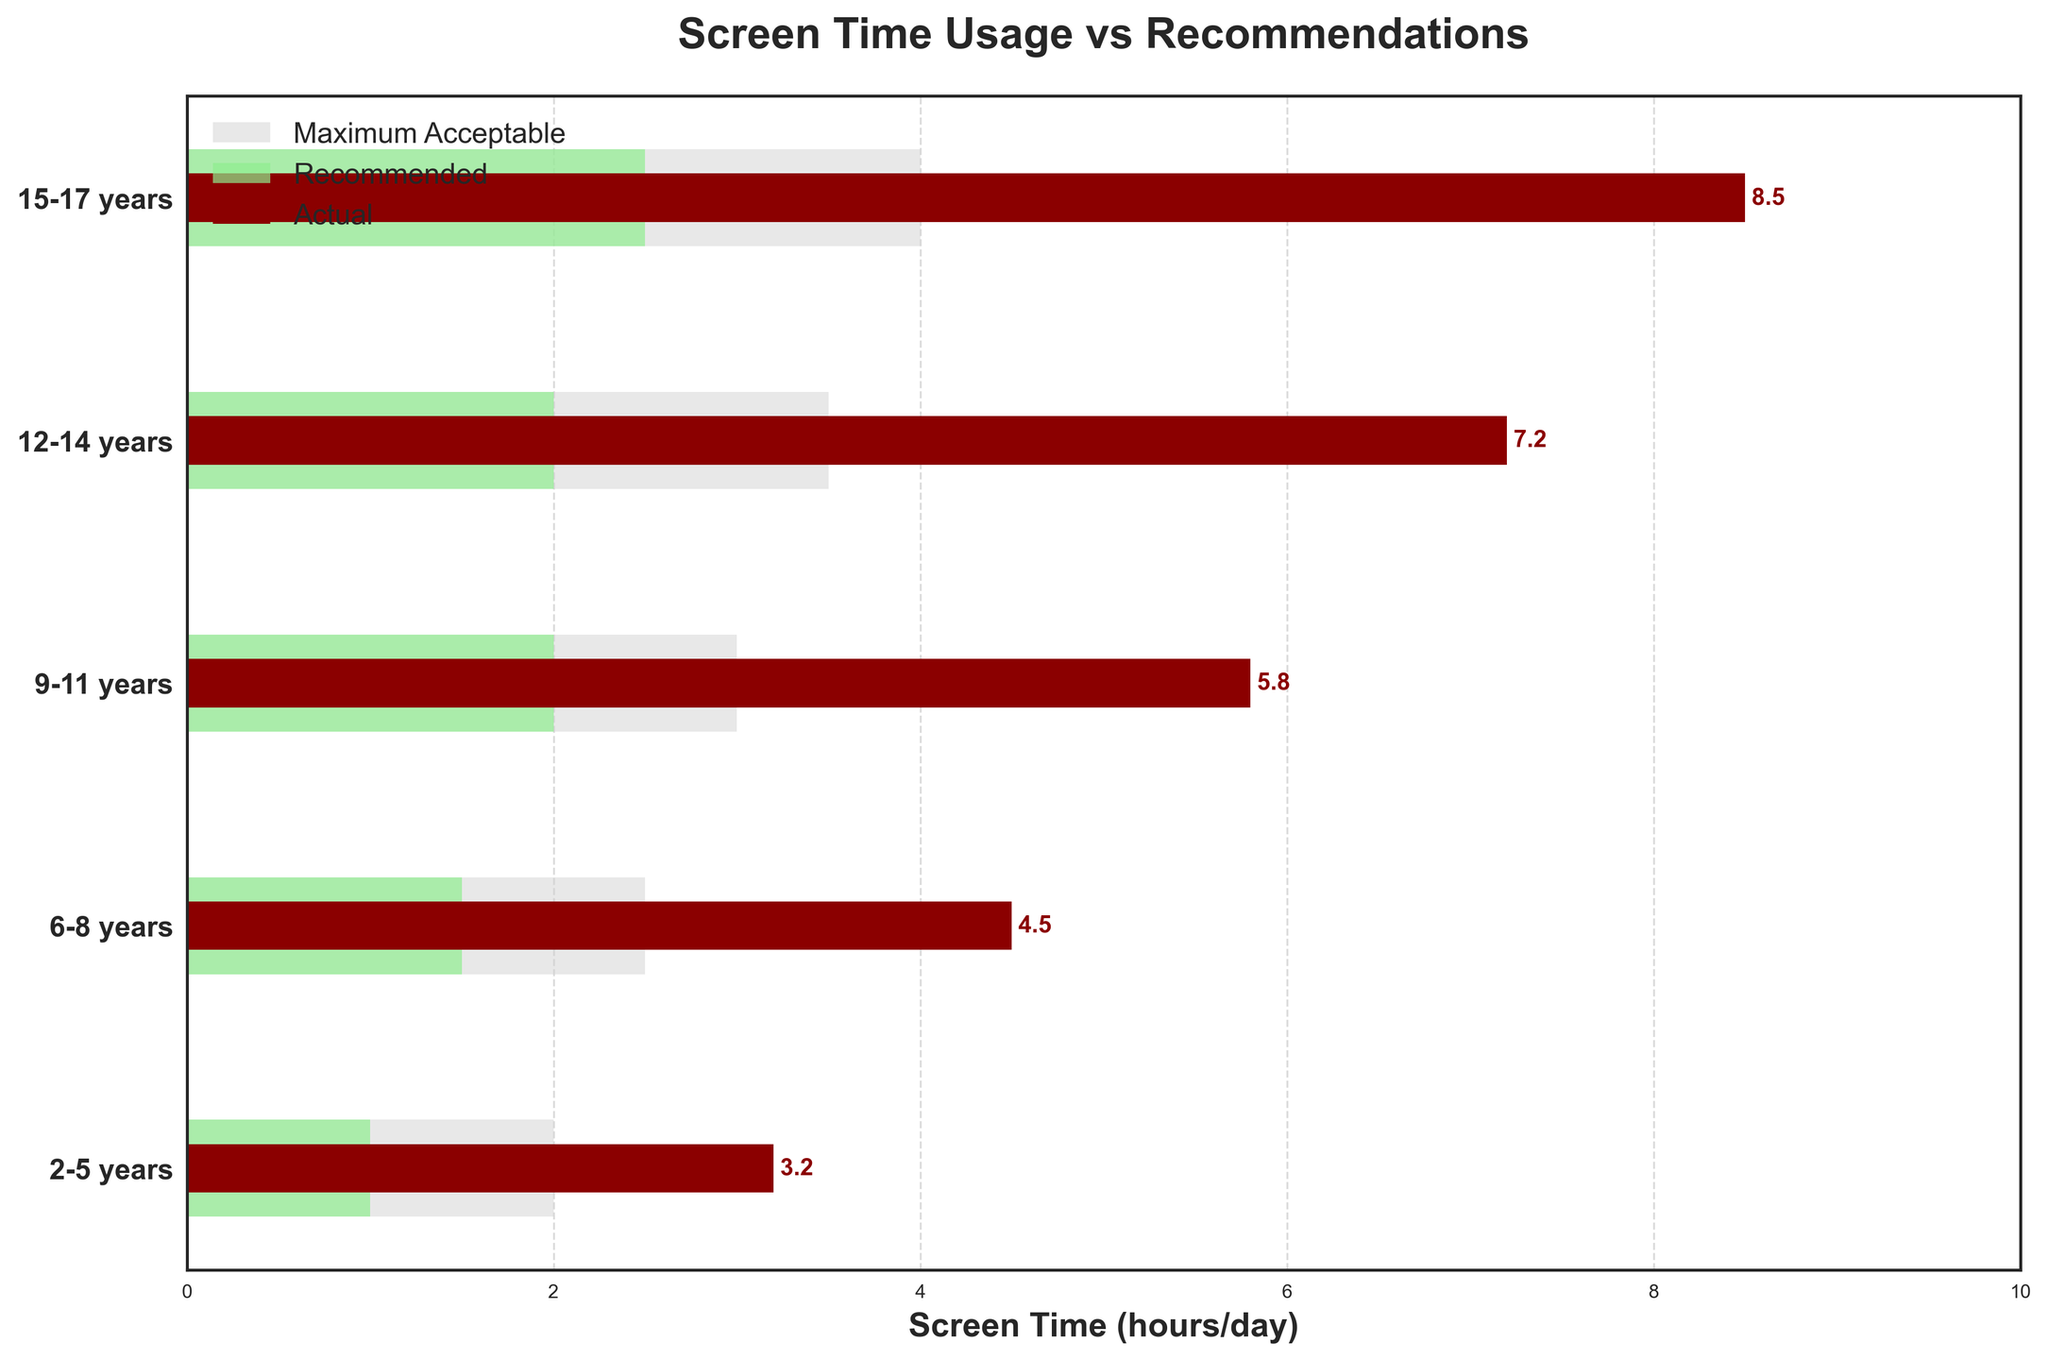Which age group has the lowest recommended screen time? Look at the green bars which represent the recommended screen times and identify the shortest bar
Answer: 2-5 years What color represents the actual screen time in the chart? Observe the bars with different colors and identify which color corresponds to the label "Actual"
Answer: Dark red What's the difference between the actual and recommended screen time for the 9-11 years age group? Find the values of the actual and recommended screen time for 9-11 years and subtract the recommended from the actual (5.8 - 2)
Answer: 3.8 hours How does the 12-14 years age group's maximum acceptable screen time compare to the 6-8 years group's maximum acceptable screen time? Compare the maximum acceptable values for both age groups by looking at the lengths of the light gray bars (3.5 for 12-14 years and 2.5 for 6-8 years)
Answer: 12-14 years is 1 hour higher Are there any age groups where the actual screen time matches the recommended screen time? Compare the dark red bars with the green bars across all age groups to see if any pairs are equal
Answer: No Which age group has the largest gap between actual screen time and maximum acceptable screen time? Calculate the differences between actual screen time and maximum acceptable for each age group and find the largest one: (8.5-4), (7.2-3.5), (5.8-3), (4.5-2.5), (3.2-2)
Answer: 15-17 years What's the average maximum acceptable screen time across all age groups? Sum all maximum acceptable screen times and divide by the number of age groups: (2 + 2.5 + 3 + 3.5 + 4) / 5
Answer: 3 hours How many different age groups are represented in the chart? Count the number of distinct age groups listed on the y-axis
Answer: 5 What's the difference in actual screen time between the 15-17 years and 2-5 years age groups? Subtract the actual screen time of 2-5 years from that of 15-17 years: (8.5 - 3.2)
Answer: 5.3 hours Which age group exceeds its maximum acceptable screen time the most? Determine the age group with the largest difference between actual and maximum acceptable screen time by comparing these differences for all age groups
Answer: 15-17 years 